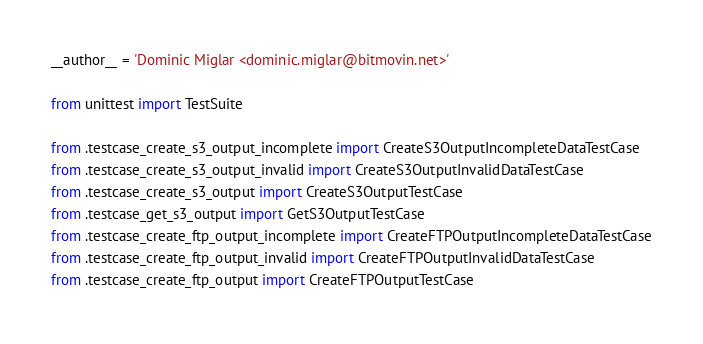Convert code to text. <code><loc_0><loc_0><loc_500><loc_500><_Python_>__author__ = 'Dominic Miglar <dominic.miglar@bitmovin.net>'

from unittest import TestSuite

from .testcase_create_s3_output_incomplete import CreateS3OutputIncompleteDataTestCase
from .testcase_create_s3_output_invalid import CreateS3OutputInvalidDataTestCase
from .testcase_create_s3_output import CreateS3OutputTestCase
from .testcase_get_s3_output import GetS3OutputTestCase
from .testcase_create_ftp_output_incomplete import CreateFTPOutputIncompleteDataTestCase
from .testcase_create_ftp_output_invalid import CreateFTPOutputInvalidDataTestCase
from .testcase_create_ftp_output import CreateFTPOutputTestCase</code> 